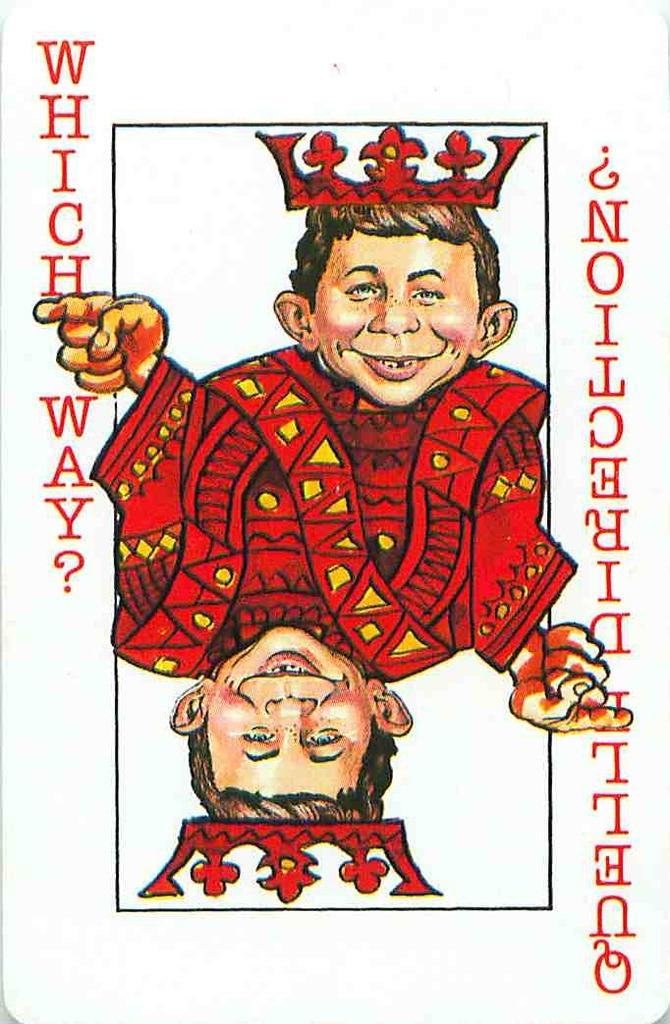What is the main object in the image? There is a card in the image. What can be seen on the card? The card has images on it. Is there any text on the card? Yes, there is writing on the card. How many books can be seen stacked next to the card in the image? There are no books visible in the image; it only features a card with images and writing. Is there a clam holding the card in the image? No, there is no clam present in the image. 